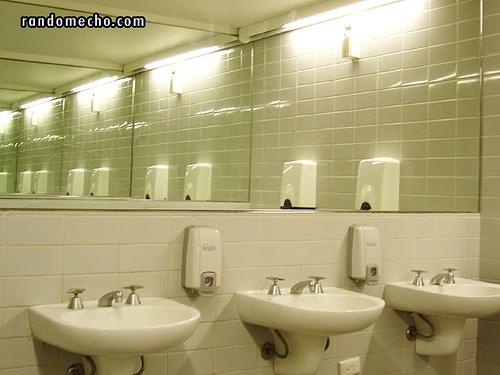How many sinks are there? three 